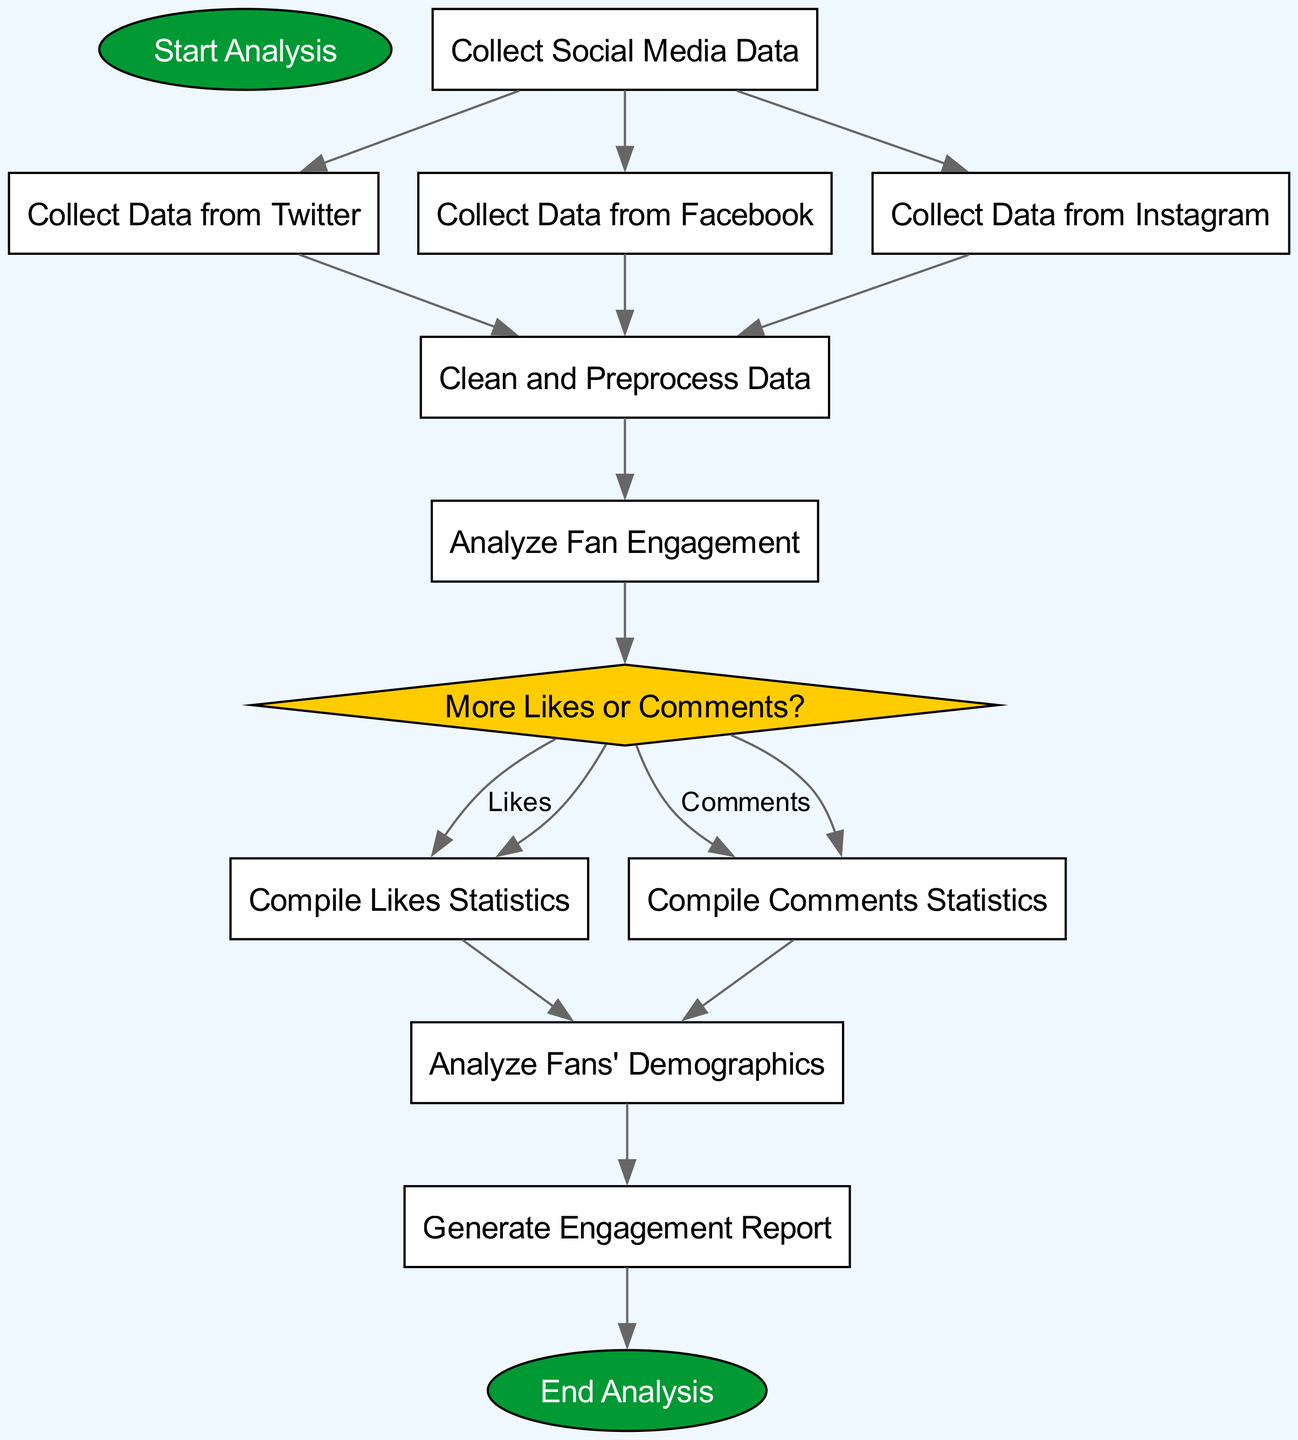What is the first step in the analysis? The first step in the flowchart is labeled "Start Analysis," indicating where the analysis process begins.
Answer: Start Analysis How many social media sources are included in the data collection? The diagram shows three nodes for social media sources: Twitter, Facebook, and Instagram. Therefore, the total is three sources.
Answer: Three What is the decision point in the flowchart? The decision point in the flowchart is represented by the "More Likes or Comments?" node, which asks a question to direct the subsequent process.
Answer: More Likes or Comments? If the choice is "Likes," what process follows next? If "Likes" is chosen at the decision point, the following process is "Compile Likes Statistics," which compiles data on likes.
Answer: Compile Likes Statistics What must be completed before analyzing fan engagement? The "Clean and Preprocess Data" step must be completed before proceeding to "Analyze Fan Engagement," as it is a prerequisite.
Answer: Clean and Preprocess Data How does the flowchart end? The flowchart ends with the node labeled "End Analysis," which indicates the completion of the entire process after generating the report.
Answer: End Analysis What processes depend on both likes and comments statistics? The process "Analyze Fans' Demographics" depends on both "Compile Likes Statistics" and "Compile Comments Statistics."
Answer: Analyze Fans' Demographics Which node indicates data collection from Facebook? The node labeled "Collect Data from Facebook" specifically indicates the step for gathering data from Facebook.
Answer: Collect Data from Facebook What type of node is "More Likes or Comments?" The node "More Likes or Comments?" is a decision node, as it poses a question that directs the flow based on the selected option.
Answer: Decision node 